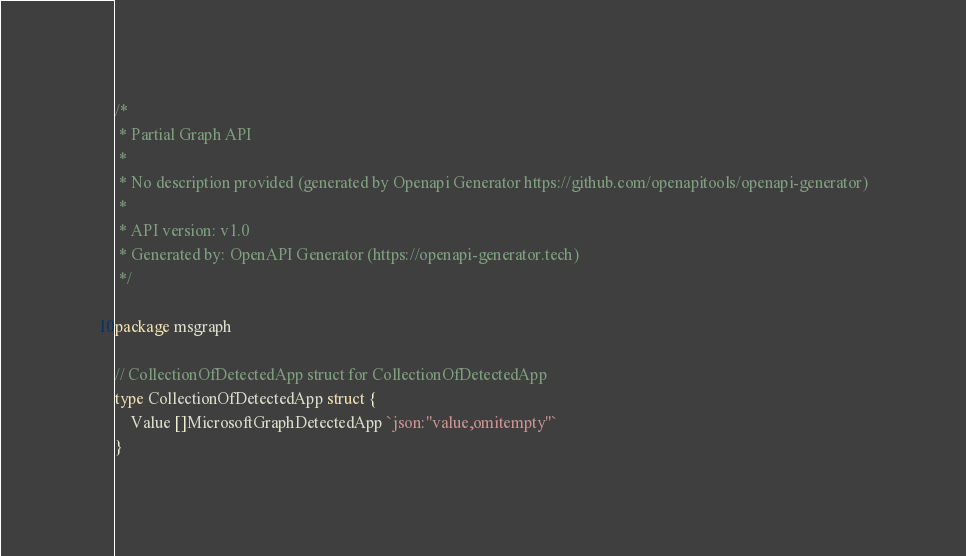Convert code to text. <code><loc_0><loc_0><loc_500><loc_500><_Go_>/*
 * Partial Graph API
 *
 * No description provided (generated by Openapi Generator https://github.com/openapitools/openapi-generator)
 *
 * API version: v1.0
 * Generated by: OpenAPI Generator (https://openapi-generator.tech)
 */

package msgraph

// CollectionOfDetectedApp struct for CollectionOfDetectedApp
type CollectionOfDetectedApp struct {
	Value []MicrosoftGraphDetectedApp `json:"value,omitempty"`
}
</code> 